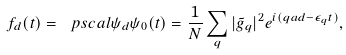Convert formula to latex. <formula><loc_0><loc_0><loc_500><loc_500>f _ { d } ( t ) = \ p s c a l { \psi _ { d } } { \psi _ { 0 } ( t ) } = \frac { 1 } { N } \sum _ { q } | \tilde { g } _ { q } | ^ { 2 } e ^ { i ( q a d - \epsilon _ { q } t ) } ,</formula> 